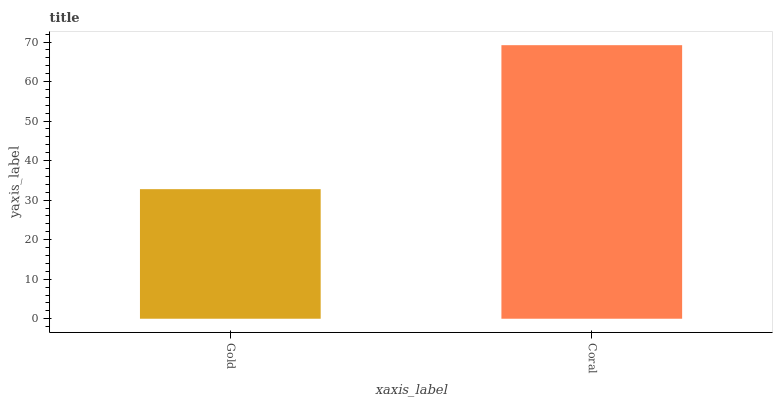Is Gold the minimum?
Answer yes or no. Yes. Is Coral the maximum?
Answer yes or no. Yes. Is Coral the minimum?
Answer yes or no. No. Is Coral greater than Gold?
Answer yes or no. Yes. Is Gold less than Coral?
Answer yes or no. Yes. Is Gold greater than Coral?
Answer yes or no. No. Is Coral less than Gold?
Answer yes or no. No. Is Coral the high median?
Answer yes or no. Yes. Is Gold the low median?
Answer yes or no. Yes. Is Gold the high median?
Answer yes or no. No. Is Coral the low median?
Answer yes or no. No. 